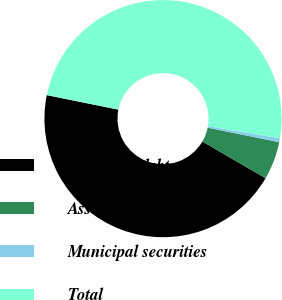Convert chart to OTSL. <chart><loc_0><loc_0><loc_500><loc_500><pie_chart><fcel>Corporate debt securities<fcel>Asset-backed securities<fcel>Municipal securities<fcel>Total<nl><fcel>44.81%<fcel>5.19%<fcel>0.53%<fcel>49.47%<nl></chart> 